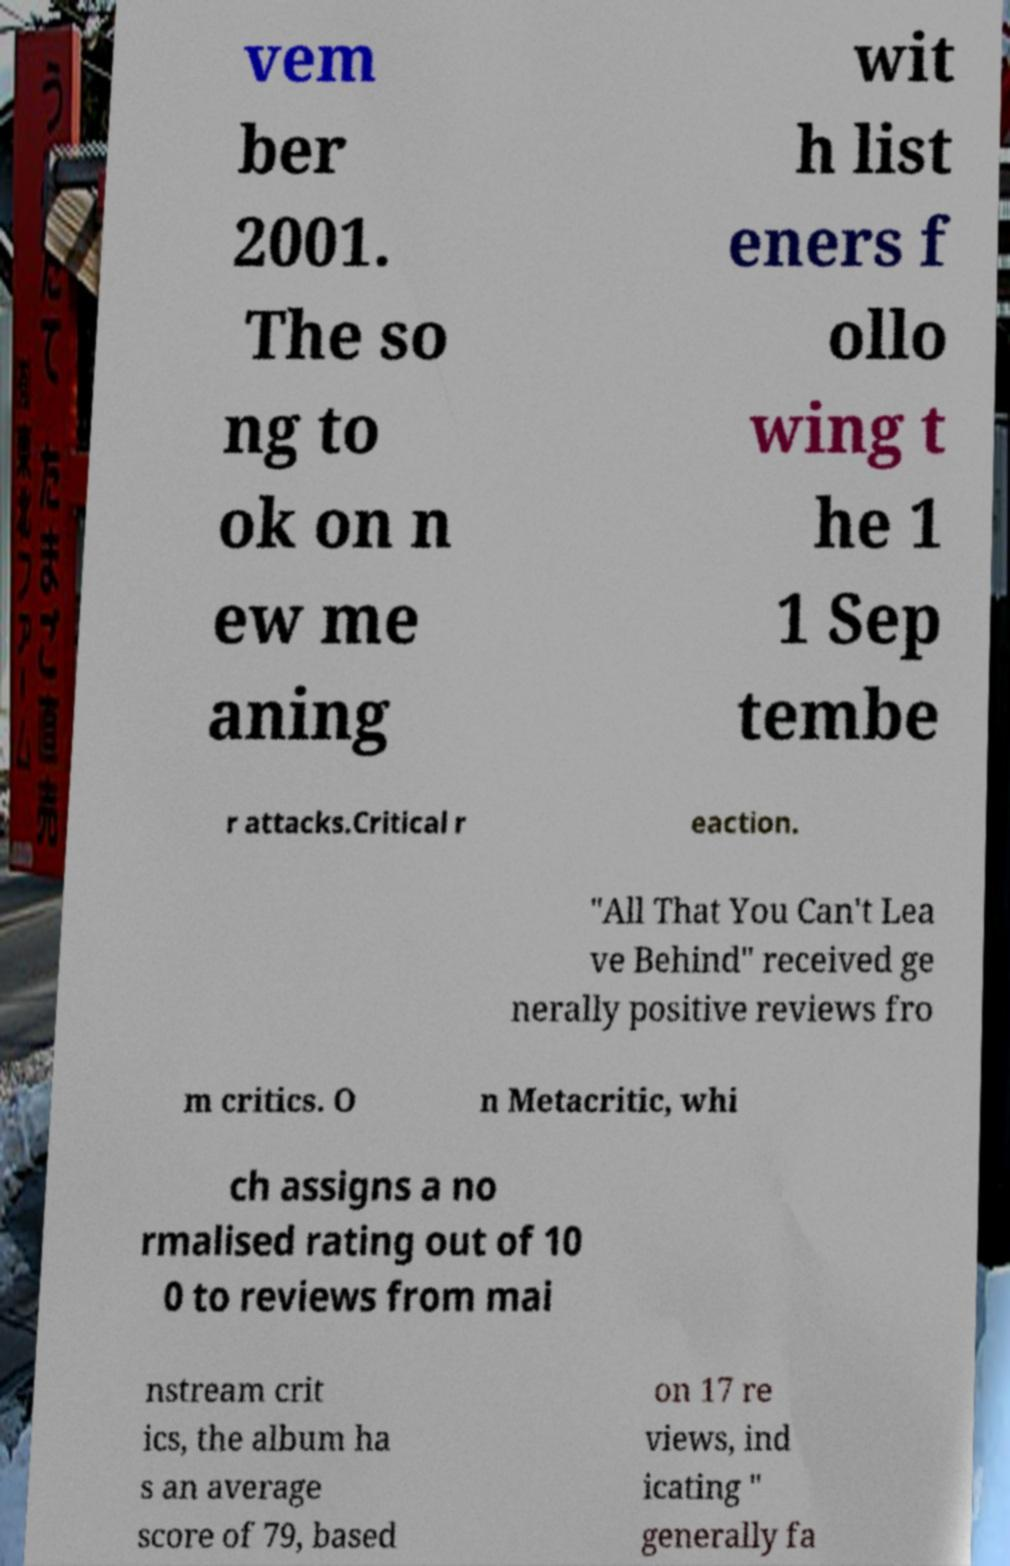Please identify and transcribe the text found in this image. vem ber 2001. The so ng to ok on n ew me aning wit h list eners f ollo wing t he 1 1 Sep tembe r attacks.Critical r eaction. "All That You Can't Lea ve Behind" received ge nerally positive reviews fro m critics. O n Metacritic, whi ch assigns a no rmalised rating out of 10 0 to reviews from mai nstream crit ics, the album ha s an average score of 79, based on 17 re views, ind icating " generally fa 